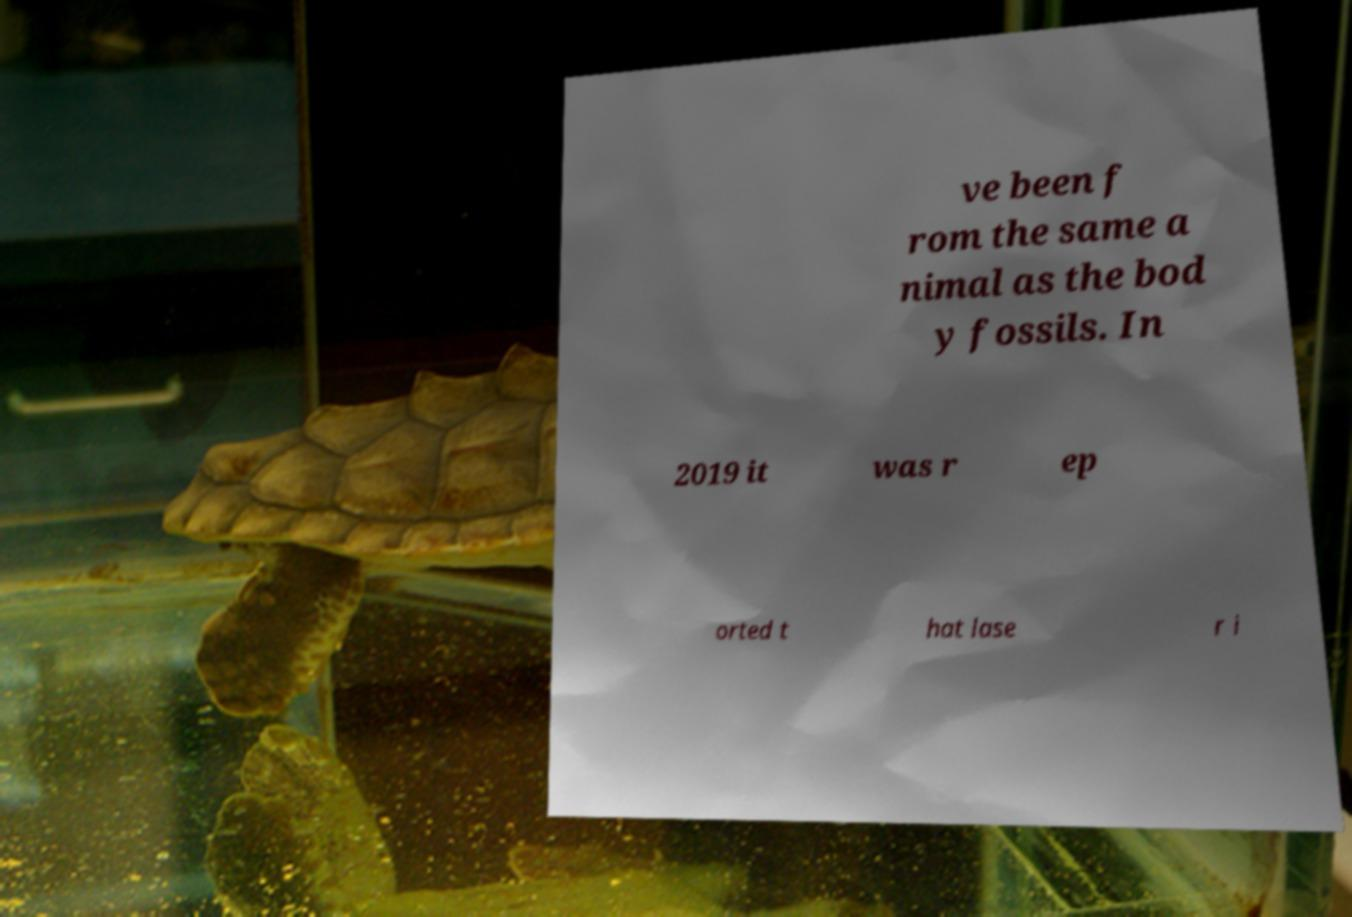Please identify and transcribe the text found in this image. ve been f rom the same a nimal as the bod y fossils. In 2019 it was r ep orted t hat lase r i 